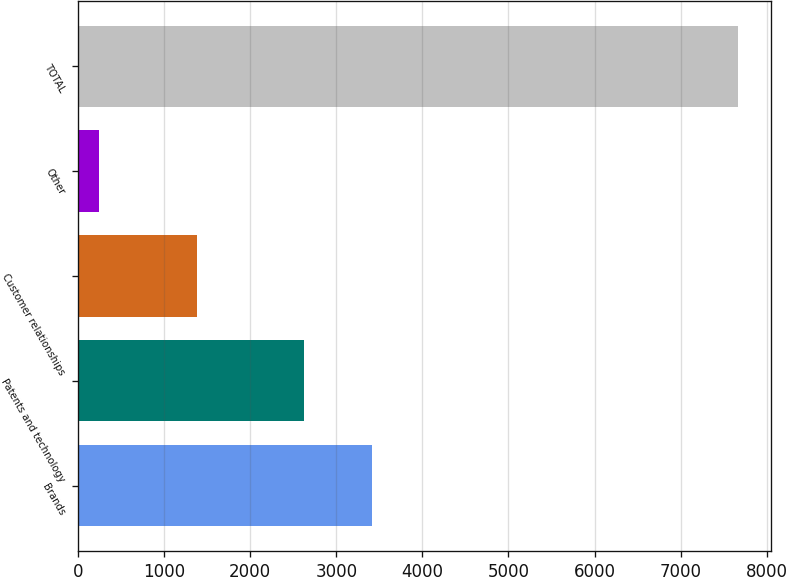Convert chart. <chart><loc_0><loc_0><loc_500><loc_500><bar_chart><fcel>Brands<fcel>Patents and technology<fcel>Customer relationships<fcel>Other<fcel>TOTAL<nl><fcel>3409<fcel>2624<fcel>1382<fcel>246<fcel>7661<nl></chart> 